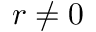Convert formula to latex. <formula><loc_0><loc_0><loc_500><loc_500>r \neq 0</formula> 